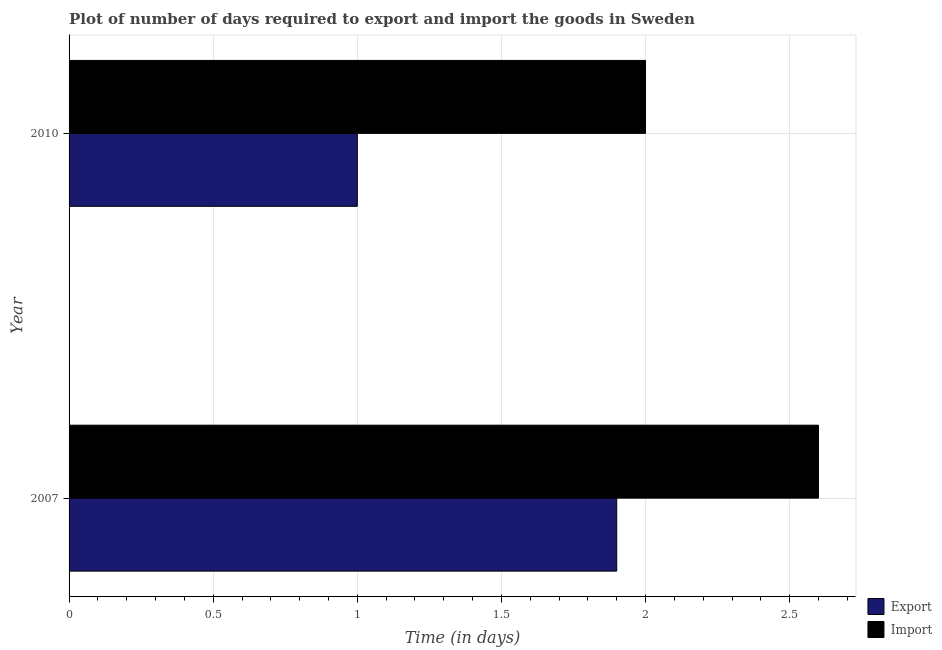How many different coloured bars are there?
Make the answer very short. 2. Are the number of bars per tick equal to the number of legend labels?
Offer a terse response. Yes. Are the number of bars on each tick of the Y-axis equal?
Your answer should be compact. Yes. How many bars are there on the 1st tick from the top?
Your answer should be very brief. 2. In how many cases, is the number of bars for a given year not equal to the number of legend labels?
Keep it short and to the point. 0. In which year was the time required to export minimum?
Your answer should be compact. 2010. What is the difference between the time required to export in 2007 and that in 2010?
Provide a succinct answer. 0.9. What is the average time required to import per year?
Ensure brevity in your answer.  2.3. In the year 2007, what is the difference between the time required to export and time required to import?
Your answer should be compact. -0.7. In how many years, is the time required to export greater than 1.5 days?
Your answer should be compact. 1. What is the ratio of the time required to export in 2007 to that in 2010?
Your answer should be compact. 1.9. Is the time required to import in 2007 less than that in 2010?
Your response must be concise. No. In how many years, is the time required to import greater than the average time required to import taken over all years?
Your response must be concise. 1. What does the 1st bar from the top in 2007 represents?
Make the answer very short. Import. What does the 2nd bar from the bottom in 2010 represents?
Provide a succinct answer. Import. Are all the bars in the graph horizontal?
Your answer should be very brief. Yes. How many years are there in the graph?
Offer a terse response. 2. Are the values on the major ticks of X-axis written in scientific E-notation?
Provide a short and direct response. No. Does the graph contain any zero values?
Provide a short and direct response. No. Does the graph contain grids?
Offer a terse response. Yes. Where does the legend appear in the graph?
Provide a succinct answer. Bottom right. What is the title of the graph?
Keep it short and to the point. Plot of number of days required to export and import the goods in Sweden. Does "Birth rate" appear as one of the legend labels in the graph?
Ensure brevity in your answer.  No. What is the label or title of the X-axis?
Give a very brief answer. Time (in days). What is the Time (in days) of Import in 2007?
Make the answer very short. 2.6. What is the Time (in days) in Import in 2010?
Your answer should be very brief. 2. Across all years, what is the maximum Time (in days) in Import?
Ensure brevity in your answer.  2.6. Across all years, what is the minimum Time (in days) of Export?
Give a very brief answer. 1. What is the total Time (in days) in Export in the graph?
Offer a very short reply. 2.9. What is the total Time (in days) of Import in the graph?
Your answer should be very brief. 4.6. What is the difference between the Time (in days) of Export in 2007 and that in 2010?
Ensure brevity in your answer.  0.9. What is the difference between the Time (in days) of Export in 2007 and the Time (in days) of Import in 2010?
Provide a short and direct response. -0.1. What is the average Time (in days) in Export per year?
Your answer should be compact. 1.45. In the year 2007, what is the difference between the Time (in days) of Export and Time (in days) of Import?
Provide a succinct answer. -0.7. What is the ratio of the Time (in days) of Export in 2007 to that in 2010?
Offer a terse response. 1.9. What is the ratio of the Time (in days) of Import in 2007 to that in 2010?
Make the answer very short. 1.3. What is the difference between the highest and the second highest Time (in days) of Export?
Make the answer very short. 0.9. What is the difference between the highest and the second highest Time (in days) in Import?
Ensure brevity in your answer.  0.6. What is the difference between the highest and the lowest Time (in days) of Import?
Your answer should be compact. 0.6. 